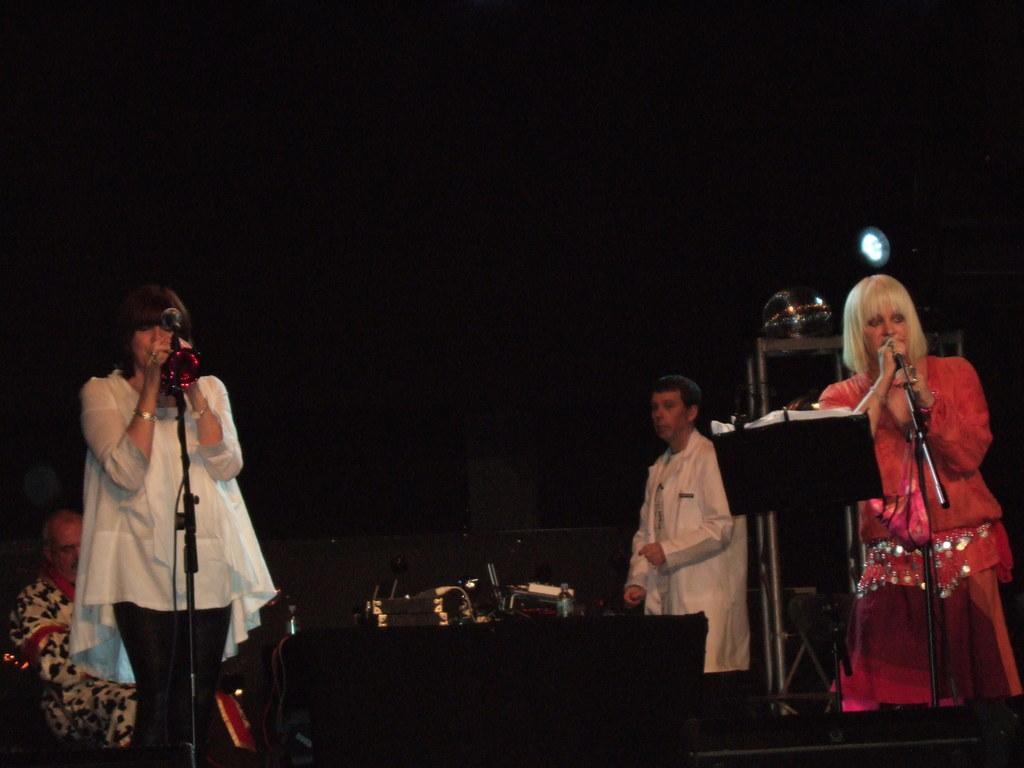Describe this image in one or two sentences. In this image I can see few people with different color dresses. I can see two people are standing in-front of the mics and one person is sitting. And there is a black background. 